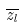<formula> <loc_0><loc_0><loc_500><loc_500>\overline { z _ { l } }</formula> 